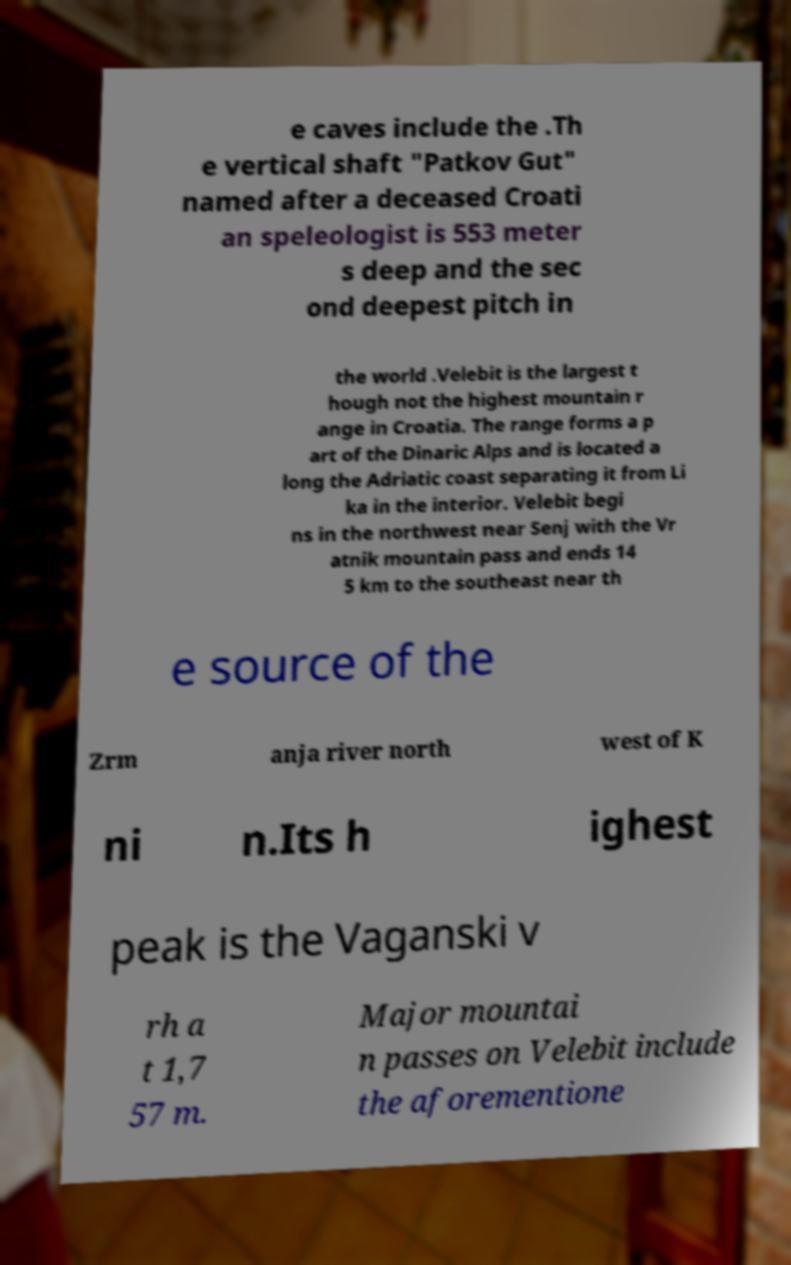Can you read and provide the text displayed in the image?This photo seems to have some interesting text. Can you extract and type it out for me? e caves include the .Th e vertical shaft "Patkov Gut" named after a deceased Croati an speleologist is 553 meter s deep and the sec ond deepest pitch in the world .Velebit is the largest t hough not the highest mountain r ange in Croatia. The range forms a p art of the Dinaric Alps and is located a long the Adriatic coast separating it from Li ka in the interior. Velebit begi ns in the northwest near Senj with the Vr atnik mountain pass and ends 14 5 km to the southeast near th e source of the Zrm anja river north west of K ni n.Its h ighest peak is the Vaganski v rh a t 1,7 57 m. Major mountai n passes on Velebit include the aforementione 